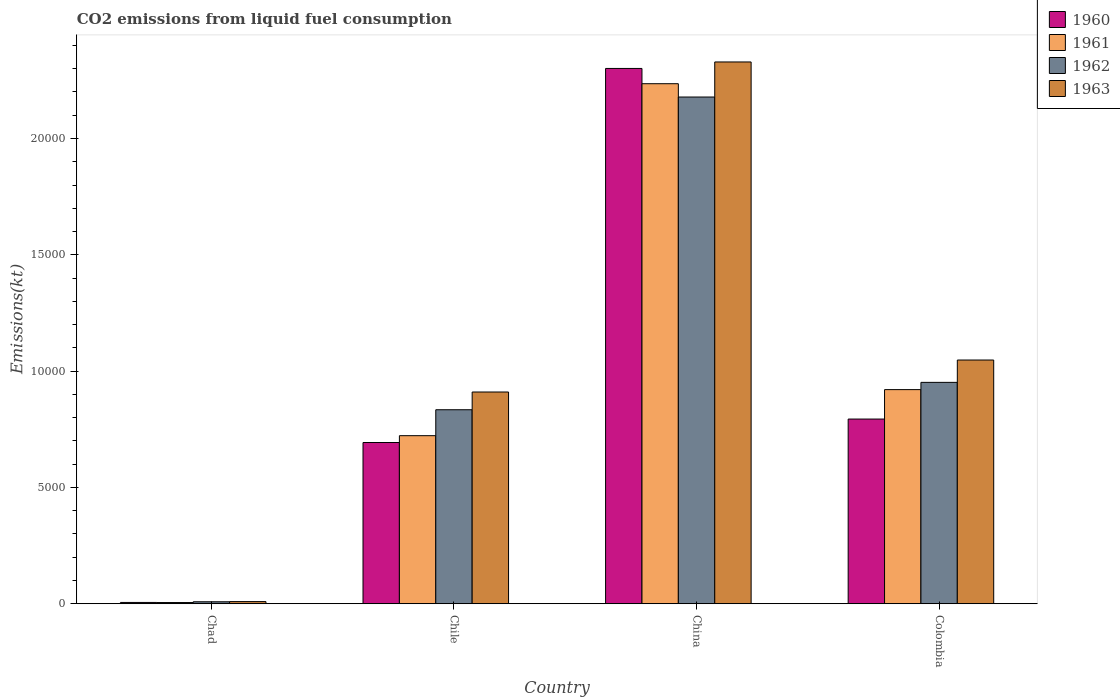How many different coloured bars are there?
Your answer should be compact. 4. How many groups of bars are there?
Provide a short and direct response. 4. Are the number of bars per tick equal to the number of legend labels?
Your answer should be very brief. Yes. Are the number of bars on each tick of the X-axis equal?
Keep it short and to the point. Yes. How many bars are there on the 4th tick from the left?
Provide a succinct answer. 4. What is the amount of CO2 emitted in 1962 in Colombia?
Offer a very short reply. 9515.86. Across all countries, what is the maximum amount of CO2 emitted in 1963?
Ensure brevity in your answer.  2.33e+04. Across all countries, what is the minimum amount of CO2 emitted in 1961?
Offer a very short reply. 51.34. In which country was the amount of CO2 emitted in 1961 minimum?
Offer a very short reply. Chad. What is the total amount of CO2 emitted in 1962 in the graph?
Your response must be concise. 3.97e+04. What is the difference between the amount of CO2 emitted in 1963 in Chad and that in Colombia?
Make the answer very short. -1.04e+04. What is the difference between the amount of CO2 emitted in 1961 in Chile and the amount of CO2 emitted in 1960 in China?
Provide a succinct answer. -1.58e+04. What is the average amount of CO2 emitted in 1960 per country?
Make the answer very short. 9483.78. What is the difference between the amount of CO2 emitted of/in 1963 and amount of CO2 emitted of/in 1962 in Colombia?
Your answer should be compact. 960.75. What is the ratio of the amount of CO2 emitted in 1962 in Chile to that in Colombia?
Your answer should be compact. 0.88. Is the difference between the amount of CO2 emitted in 1963 in Chad and Chile greater than the difference between the amount of CO2 emitted in 1962 in Chad and Chile?
Your answer should be compact. No. What is the difference between the highest and the second highest amount of CO2 emitted in 1962?
Your answer should be compact. -1177.11. What is the difference between the highest and the lowest amount of CO2 emitted in 1961?
Make the answer very short. 2.23e+04. Is the sum of the amount of CO2 emitted in 1961 in Chad and Chile greater than the maximum amount of CO2 emitted in 1963 across all countries?
Your response must be concise. No. What does the 3rd bar from the right in Chad represents?
Your answer should be very brief. 1961. How many bars are there?
Provide a short and direct response. 16. What is the difference between two consecutive major ticks on the Y-axis?
Your answer should be very brief. 5000. How many legend labels are there?
Provide a short and direct response. 4. What is the title of the graph?
Offer a very short reply. CO2 emissions from liquid fuel consumption. What is the label or title of the Y-axis?
Your answer should be compact. Emissions(kt). What is the Emissions(kt) in 1960 in Chad?
Your response must be concise. 55.01. What is the Emissions(kt) of 1961 in Chad?
Provide a short and direct response. 51.34. What is the Emissions(kt) of 1962 in Chad?
Your response must be concise. 84.34. What is the Emissions(kt) of 1963 in Chad?
Your answer should be very brief. 91.67. What is the Emissions(kt) of 1960 in Chile?
Your answer should be very brief. 6930.63. What is the Emissions(kt) in 1961 in Chile?
Offer a very short reply. 7223.99. What is the Emissions(kt) of 1962 in Chile?
Your answer should be very brief. 8338.76. What is the Emissions(kt) of 1963 in Chile?
Your answer should be compact. 9101.49. What is the Emissions(kt) of 1960 in China?
Ensure brevity in your answer.  2.30e+04. What is the Emissions(kt) of 1961 in China?
Make the answer very short. 2.24e+04. What is the Emissions(kt) of 1962 in China?
Provide a short and direct response. 2.18e+04. What is the Emissions(kt) in 1963 in China?
Offer a terse response. 2.33e+04. What is the Emissions(kt) in 1960 in Colombia?
Make the answer very short. 7939.06. What is the Emissions(kt) in 1961 in Colombia?
Ensure brevity in your answer.  9204.17. What is the Emissions(kt) in 1962 in Colombia?
Offer a terse response. 9515.86. What is the Emissions(kt) in 1963 in Colombia?
Ensure brevity in your answer.  1.05e+04. Across all countries, what is the maximum Emissions(kt) of 1960?
Your answer should be compact. 2.30e+04. Across all countries, what is the maximum Emissions(kt) of 1961?
Your answer should be compact. 2.24e+04. Across all countries, what is the maximum Emissions(kt) in 1962?
Offer a very short reply. 2.18e+04. Across all countries, what is the maximum Emissions(kt) of 1963?
Provide a short and direct response. 2.33e+04. Across all countries, what is the minimum Emissions(kt) of 1960?
Offer a very short reply. 55.01. Across all countries, what is the minimum Emissions(kt) of 1961?
Give a very brief answer. 51.34. Across all countries, what is the minimum Emissions(kt) in 1962?
Your response must be concise. 84.34. Across all countries, what is the minimum Emissions(kt) in 1963?
Ensure brevity in your answer.  91.67. What is the total Emissions(kt) in 1960 in the graph?
Your response must be concise. 3.79e+04. What is the total Emissions(kt) of 1961 in the graph?
Make the answer very short. 3.88e+04. What is the total Emissions(kt) of 1962 in the graph?
Your answer should be very brief. 3.97e+04. What is the total Emissions(kt) in 1963 in the graph?
Keep it short and to the point. 4.30e+04. What is the difference between the Emissions(kt) of 1960 in Chad and that in Chile?
Your answer should be compact. -6875.62. What is the difference between the Emissions(kt) of 1961 in Chad and that in Chile?
Make the answer very short. -7172.65. What is the difference between the Emissions(kt) in 1962 in Chad and that in Chile?
Keep it short and to the point. -8254.42. What is the difference between the Emissions(kt) of 1963 in Chad and that in Chile?
Provide a succinct answer. -9009.82. What is the difference between the Emissions(kt) of 1960 in Chad and that in China?
Provide a succinct answer. -2.30e+04. What is the difference between the Emissions(kt) of 1961 in Chad and that in China?
Offer a very short reply. -2.23e+04. What is the difference between the Emissions(kt) in 1962 in Chad and that in China?
Make the answer very short. -2.17e+04. What is the difference between the Emissions(kt) in 1963 in Chad and that in China?
Offer a very short reply. -2.32e+04. What is the difference between the Emissions(kt) of 1960 in Chad and that in Colombia?
Provide a short and direct response. -7884.05. What is the difference between the Emissions(kt) of 1961 in Chad and that in Colombia?
Provide a short and direct response. -9152.83. What is the difference between the Emissions(kt) in 1962 in Chad and that in Colombia?
Give a very brief answer. -9431.52. What is the difference between the Emissions(kt) in 1963 in Chad and that in Colombia?
Your answer should be very brief. -1.04e+04. What is the difference between the Emissions(kt) in 1960 in Chile and that in China?
Offer a terse response. -1.61e+04. What is the difference between the Emissions(kt) in 1961 in Chile and that in China?
Keep it short and to the point. -1.51e+04. What is the difference between the Emissions(kt) in 1962 in Chile and that in China?
Your answer should be compact. -1.34e+04. What is the difference between the Emissions(kt) of 1963 in Chile and that in China?
Provide a succinct answer. -1.42e+04. What is the difference between the Emissions(kt) in 1960 in Chile and that in Colombia?
Make the answer very short. -1008.42. What is the difference between the Emissions(kt) of 1961 in Chile and that in Colombia?
Give a very brief answer. -1980.18. What is the difference between the Emissions(kt) of 1962 in Chile and that in Colombia?
Make the answer very short. -1177.11. What is the difference between the Emissions(kt) of 1963 in Chile and that in Colombia?
Your response must be concise. -1375.12. What is the difference between the Emissions(kt) in 1960 in China and that in Colombia?
Ensure brevity in your answer.  1.51e+04. What is the difference between the Emissions(kt) in 1961 in China and that in Colombia?
Offer a very short reply. 1.31e+04. What is the difference between the Emissions(kt) in 1962 in China and that in Colombia?
Your response must be concise. 1.23e+04. What is the difference between the Emissions(kt) in 1963 in China and that in Colombia?
Make the answer very short. 1.28e+04. What is the difference between the Emissions(kt) in 1960 in Chad and the Emissions(kt) in 1961 in Chile?
Provide a succinct answer. -7168.98. What is the difference between the Emissions(kt) of 1960 in Chad and the Emissions(kt) of 1962 in Chile?
Ensure brevity in your answer.  -8283.75. What is the difference between the Emissions(kt) in 1960 in Chad and the Emissions(kt) in 1963 in Chile?
Offer a terse response. -9046.49. What is the difference between the Emissions(kt) in 1961 in Chad and the Emissions(kt) in 1962 in Chile?
Your answer should be compact. -8287.42. What is the difference between the Emissions(kt) of 1961 in Chad and the Emissions(kt) of 1963 in Chile?
Ensure brevity in your answer.  -9050.16. What is the difference between the Emissions(kt) of 1962 in Chad and the Emissions(kt) of 1963 in Chile?
Your response must be concise. -9017.15. What is the difference between the Emissions(kt) of 1960 in Chad and the Emissions(kt) of 1961 in China?
Your answer should be very brief. -2.23e+04. What is the difference between the Emissions(kt) of 1960 in Chad and the Emissions(kt) of 1962 in China?
Ensure brevity in your answer.  -2.17e+04. What is the difference between the Emissions(kt) in 1960 in Chad and the Emissions(kt) in 1963 in China?
Keep it short and to the point. -2.32e+04. What is the difference between the Emissions(kt) of 1961 in Chad and the Emissions(kt) of 1962 in China?
Make the answer very short. -2.17e+04. What is the difference between the Emissions(kt) of 1961 in Chad and the Emissions(kt) of 1963 in China?
Your answer should be compact. -2.32e+04. What is the difference between the Emissions(kt) in 1962 in Chad and the Emissions(kt) in 1963 in China?
Give a very brief answer. -2.32e+04. What is the difference between the Emissions(kt) in 1960 in Chad and the Emissions(kt) in 1961 in Colombia?
Provide a succinct answer. -9149.17. What is the difference between the Emissions(kt) of 1960 in Chad and the Emissions(kt) of 1962 in Colombia?
Keep it short and to the point. -9460.86. What is the difference between the Emissions(kt) of 1960 in Chad and the Emissions(kt) of 1963 in Colombia?
Offer a very short reply. -1.04e+04. What is the difference between the Emissions(kt) in 1961 in Chad and the Emissions(kt) in 1962 in Colombia?
Offer a very short reply. -9464.53. What is the difference between the Emissions(kt) of 1961 in Chad and the Emissions(kt) of 1963 in Colombia?
Make the answer very short. -1.04e+04. What is the difference between the Emissions(kt) in 1962 in Chad and the Emissions(kt) in 1963 in Colombia?
Your response must be concise. -1.04e+04. What is the difference between the Emissions(kt) in 1960 in Chile and the Emissions(kt) in 1961 in China?
Offer a very short reply. -1.54e+04. What is the difference between the Emissions(kt) of 1960 in Chile and the Emissions(kt) of 1962 in China?
Offer a very short reply. -1.49e+04. What is the difference between the Emissions(kt) of 1960 in Chile and the Emissions(kt) of 1963 in China?
Offer a very short reply. -1.64e+04. What is the difference between the Emissions(kt) of 1961 in Chile and the Emissions(kt) of 1962 in China?
Ensure brevity in your answer.  -1.46e+04. What is the difference between the Emissions(kt) in 1961 in Chile and the Emissions(kt) in 1963 in China?
Provide a short and direct response. -1.61e+04. What is the difference between the Emissions(kt) in 1962 in Chile and the Emissions(kt) in 1963 in China?
Offer a very short reply. -1.50e+04. What is the difference between the Emissions(kt) in 1960 in Chile and the Emissions(kt) in 1961 in Colombia?
Offer a very short reply. -2273.54. What is the difference between the Emissions(kt) in 1960 in Chile and the Emissions(kt) in 1962 in Colombia?
Make the answer very short. -2585.24. What is the difference between the Emissions(kt) of 1960 in Chile and the Emissions(kt) of 1963 in Colombia?
Your answer should be very brief. -3545.99. What is the difference between the Emissions(kt) in 1961 in Chile and the Emissions(kt) in 1962 in Colombia?
Keep it short and to the point. -2291.88. What is the difference between the Emissions(kt) of 1961 in Chile and the Emissions(kt) of 1963 in Colombia?
Provide a succinct answer. -3252.63. What is the difference between the Emissions(kt) of 1962 in Chile and the Emissions(kt) of 1963 in Colombia?
Keep it short and to the point. -2137.86. What is the difference between the Emissions(kt) of 1960 in China and the Emissions(kt) of 1961 in Colombia?
Give a very brief answer. 1.38e+04. What is the difference between the Emissions(kt) of 1960 in China and the Emissions(kt) of 1962 in Colombia?
Your response must be concise. 1.35e+04. What is the difference between the Emissions(kt) in 1960 in China and the Emissions(kt) in 1963 in Colombia?
Give a very brief answer. 1.25e+04. What is the difference between the Emissions(kt) of 1961 in China and the Emissions(kt) of 1962 in Colombia?
Offer a very short reply. 1.28e+04. What is the difference between the Emissions(kt) of 1961 in China and the Emissions(kt) of 1963 in Colombia?
Keep it short and to the point. 1.19e+04. What is the difference between the Emissions(kt) in 1962 in China and the Emissions(kt) in 1963 in Colombia?
Give a very brief answer. 1.13e+04. What is the average Emissions(kt) of 1960 per country?
Your answer should be very brief. 9483.78. What is the average Emissions(kt) of 1961 per country?
Your answer should be very brief. 9708.38. What is the average Emissions(kt) of 1962 per country?
Offer a terse response. 9930.24. What is the average Emissions(kt) of 1963 per country?
Offer a very short reply. 1.07e+04. What is the difference between the Emissions(kt) in 1960 and Emissions(kt) in 1961 in Chad?
Provide a succinct answer. 3.67. What is the difference between the Emissions(kt) of 1960 and Emissions(kt) of 1962 in Chad?
Offer a very short reply. -29.34. What is the difference between the Emissions(kt) of 1960 and Emissions(kt) of 1963 in Chad?
Ensure brevity in your answer.  -36.67. What is the difference between the Emissions(kt) of 1961 and Emissions(kt) of 1962 in Chad?
Give a very brief answer. -33. What is the difference between the Emissions(kt) of 1961 and Emissions(kt) of 1963 in Chad?
Provide a succinct answer. -40.34. What is the difference between the Emissions(kt) of 1962 and Emissions(kt) of 1963 in Chad?
Ensure brevity in your answer.  -7.33. What is the difference between the Emissions(kt) of 1960 and Emissions(kt) of 1961 in Chile?
Your answer should be compact. -293.36. What is the difference between the Emissions(kt) in 1960 and Emissions(kt) in 1962 in Chile?
Make the answer very short. -1408.13. What is the difference between the Emissions(kt) in 1960 and Emissions(kt) in 1963 in Chile?
Provide a short and direct response. -2170.86. What is the difference between the Emissions(kt) in 1961 and Emissions(kt) in 1962 in Chile?
Provide a short and direct response. -1114.77. What is the difference between the Emissions(kt) of 1961 and Emissions(kt) of 1963 in Chile?
Give a very brief answer. -1877.5. What is the difference between the Emissions(kt) of 1962 and Emissions(kt) of 1963 in Chile?
Ensure brevity in your answer.  -762.74. What is the difference between the Emissions(kt) of 1960 and Emissions(kt) of 1961 in China?
Your response must be concise. 656.39. What is the difference between the Emissions(kt) of 1960 and Emissions(kt) of 1962 in China?
Your answer should be compact. 1228.44. What is the difference between the Emissions(kt) in 1960 and Emissions(kt) in 1963 in China?
Your answer should be very brief. -278.69. What is the difference between the Emissions(kt) in 1961 and Emissions(kt) in 1962 in China?
Keep it short and to the point. 572.05. What is the difference between the Emissions(kt) of 1961 and Emissions(kt) of 1963 in China?
Give a very brief answer. -935.09. What is the difference between the Emissions(kt) in 1962 and Emissions(kt) in 1963 in China?
Your answer should be compact. -1507.14. What is the difference between the Emissions(kt) in 1960 and Emissions(kt) in 1961 in Colombia?
Your response must be concise. -1265.12. What is the difference between the Emissions(kt) in 1960 and Emissions(kt) in 1962 in Colombia?
Ensure brevity in your answer.  -1576.81. What is the difference between the Emissions(kt) in 1960 and Emissions(kt) in 1963 in Colombia?
Keep it short and to the point. -2537.56. What is the difference between the Emissions(kt) of 1961 and Emissions(kt) of 1962 in Colombia?
Provide a short and direct response. -311.69. What is the difference between the Emissions(kt) in 1961 and Emissions(kt) in 1963 in Colombia?
Ensure brevity in your answer.  -1272.45. What is the difference between the Emissions(kt) in 1962 and Emissions(kt) in 1963 in Colombia?
Provide a short and direct response. -960.75. What is the ratio of the Emissions(kt) in 1960 in Chad to that in Chile?
Your answer should be compact. 0.01. What is the ratio of the Emissions(kt) of 1961 in Chad to that in Chile?
Offer a very short reply. 0.01. What is the ratio of the Emissions(kt) in 1962 in Chad to that in Chile?
Offer a very short reply. 0.01. What is the ratio of the Emissions(kt) of 1963 in Chad to that in Chile?
Give a very brief answer. 0.01. What is the ratio of the Emissions(kt) of 1960 in Chad to that in China?
Your answer should be very brief. 0. What is the ratio of the Emissions(kt) in 1961 in Chad to that in China?
Make the answer very short. 0. What is the ratio of the Emissions(kt) of 1962 in Chad to that in China?
Your answer should be very brief. 0. What is the ratio of the Emissions(kt) in 1963 in Chad to that in China?
Keep it short and to the point. 0. What is the ratio of the Emissions(kt) in 1960 in Chad to that in Colombia?
Your answer should be compact. 0.01. What is the ratio of the Emissions(kt) in 1961 in Chad to that in Colombia?
Provide a short and direct response. 0.01. What is the ratio of the Emissions(kt) of 1962 in Chad to that in Colombia?
Offer a terse response. 0.01. What is the ratio of the Emissions(kt) in 1963 in Chad to that in Colombia?
Keep it short and to the point. 0.01. What is the ratio of the Emissions(kt) of 1960 in Chile to that in China?
Offer a very short reply. 0.3. What is the ratio of the Emissions(kt) of 1961 in Chile to that in China?
Provide a short and direct response. 0.32. What is the ratio of the Emissions(kt) of 1962 in Chile to that in China?
Your response must be concise. 0.38. What is the ratio of the Emissions(kt) in 1963 in Chile to that in China?
Provide a succinct answer. 0.39. What is the ratio of the Emissions(kt) in 1960 in Chile to that in Colombia?
Provide a short and direct response. 0.87. What is the ratio of the Emissions(kt) of 1961 in Chile to that in Colombia?
Ensure brevity in your answer.  0.78. What is the ratio of the Emissions(kt) of 1962 in Chile to that in Colombia?
Make the answer very short. 0.88. What is the ratio of the Emissions(kt) of 1963 in Chile to that in Colombia?
Provide a succinct answer. 0.87. What is the ratio of the Emissions(kt) of 1960 in China to that in Colombia?
Give a very brief answer. 2.9. What is the ratio of the Emissions(kt) of 1961 in China to that in Colombia?
Provide a succinct answer. 2.43. What is the ratio of the Emissions(kt) of 1962 in China to that in Colombia?
Keep it short and to the point. 2.29. What is the ratio of the Emissions(kt) in 1963 in China to that in Colombia?
Your answer should be compact. 2.22. What is the difference between the highest and the second highest Emissions(kt) in 1960?
Give a very brief answer. 1.51e+04. What is the difference between the highest and the second highest Emissions(kt) of 1961?
Make the answer very short. 1.31e+04. What is the difference between the highest and the second highest Emissions(kt) in 1962?
Provide a short and direct response. 1.23e+04. What is the difference between the highest and the second highest Emissions(kt) of 1963?
Provide a short and direct response. 1.28e+04. What is the difference between the highest and the lowest Emissions(kt) in 1960?
Your response must be concise. 2.30e+04. What is the difference between the highest and the lowest Emissions(kt) of 1961?
Your response must be concise. 2.23e+04. What is the difference between the highest and the lowest Emissions(kt) of 1962?
Offer a terse response. 2.17e+04. What is the difference between the highest and the lowest Emissions(kt) in 1963?
Make the answer very short. 2.32e+04. 